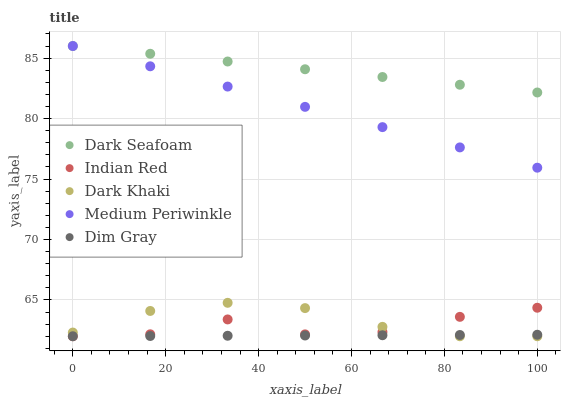Does Dim Gray have the minimum area under the curve?
Answer yes or no. Yes. Does Dark Seafoam have the maximum area under the curve?
Answer yes or no. Yes. Does Dark Seafoam have the minimum area under the curve?
Answer yes or no. No. Does Dim Gray have the maximum area under the curve?
Answer yes or no. No. Is Dim Gray the smoothest?
Answer yes or no. Yes. Is Indian Red the roughest?
Answer yes or no. Yes. Is Dark Seafoam the smoothest?
Answer yes or no. No. Is Dark Seafoam the roughest?
Answer yes or no. No. Does Dark Khaki have the lowest value?
Answer yes or no. Yes. Does Dark Seafoam have the lowest value?
Answer yes or no. No. Does Medium Periwinkle have the highest value?
Answer yes or no. Yes. Does Dim Gray have the highest value?
Answer yes or no. No. Is Dim Gray less than Medium Periwinkle?
Answer yes or no. Yes. Is Dark Seafoam greater than Dim Gray?
Answer yes or no. Yes. Does Dark Khaki intersect Dim Gray?
Answer yes or no. Yes. Is Dark Khaki less than Dim Gray?
Answer yes or no. No. Is Dark Khaki greater than Dim Gray?
Answer yes or no. No. Does Dim Gray intersect Medium Periwinkle?
Answer yes or no. No. 